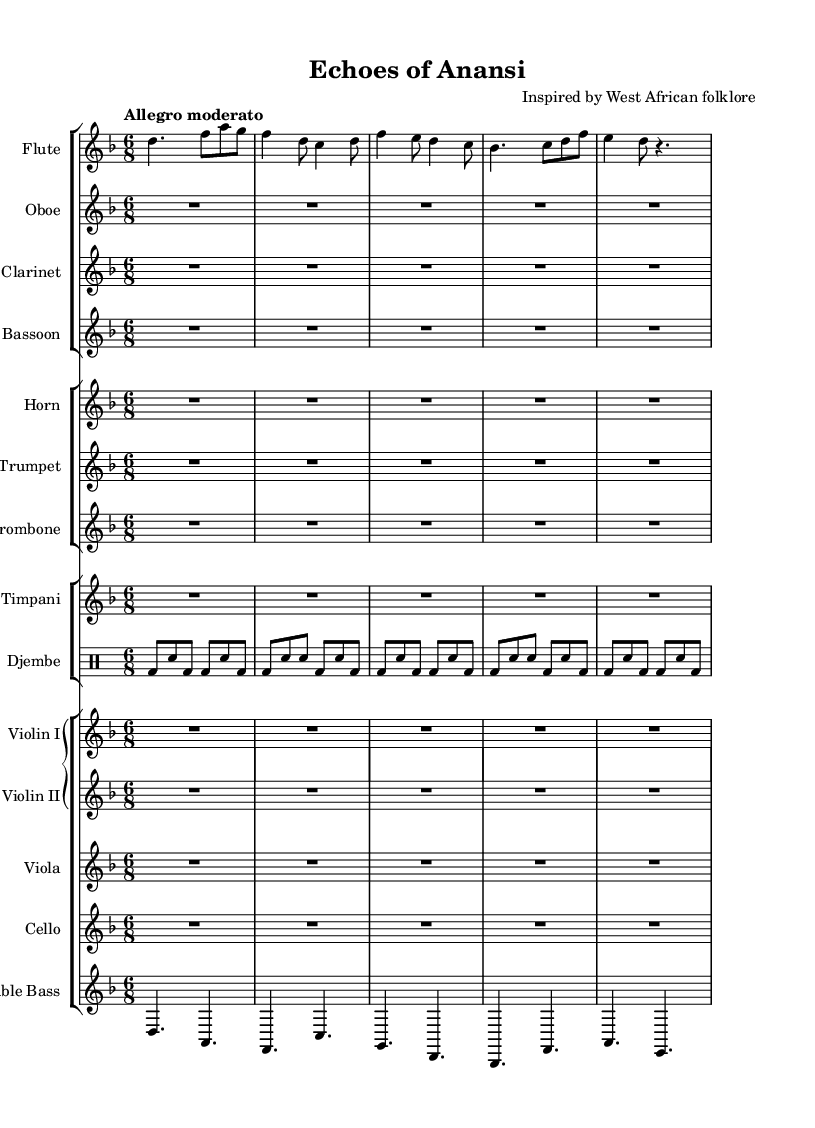What is the key signature of this music? The key signature is indicated at the beginning of the sheet music, showing two flats, which corresponds to the key of D minor.
Answer: D minor What is the time signature of this piece? The time signature is shown next to the key signature, indicating a compound meter with six eighth notes per measure, represented as 6/8.
Answer: 6/8 What is the tempo marking for this symphony? The tempo marking, found near the top of the score, reads "Allegro moderato," suggesting a moderately fast pace.
Answer: Allegro moderato How many measures are present in the flute part? By counting the sections in the flute part, we find there are eight measures present in the notation.
Answer: Eight What type of drum is featured in this symphony? The type of drum notated in the sheet music is a djembe, which is indicated in the drum staff.
Answer: Djembe Which instruments are combined in the first staff group? The first staff group contains the Flute, Oboe, Clarinet, and Bassoon, as indicated by the labeling of each staff.
Answer: Flute, Oboe, Clarinet, Bassoon What instrument plays the lowest notes in this symphony? The instrument with the lowest pitch is indicated at the bottom of the Grand Staff as the Double Bass.
Answer: Double Bass 